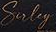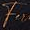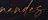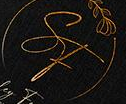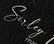Read the text content from these images in order, separated by a semicolon. Suley; Fu; #####; SF; Suley 